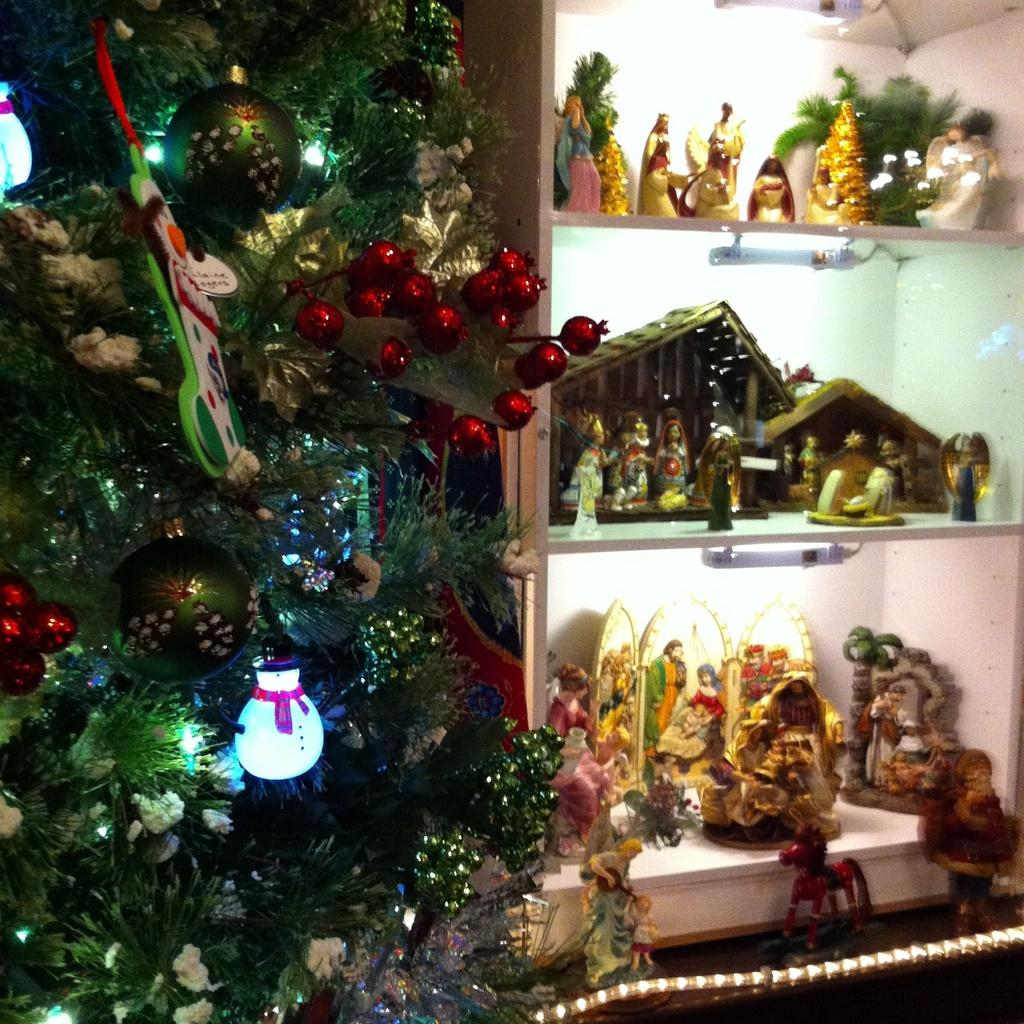What type of tree is in the image? There is a Christmas tree in the image. Where is the Christmas tree located in the image? The Christmas tree is on the left side of the image. What can be seen on the right side of the image? There are many statues on a shelf in the image. Where is the shelf with statues located in the image? The shelf with statues is on the right side of the image. What type of toy is coiled around the Christmas tree in the image? There is no toy or coil present around the Christmas tree in the image. 